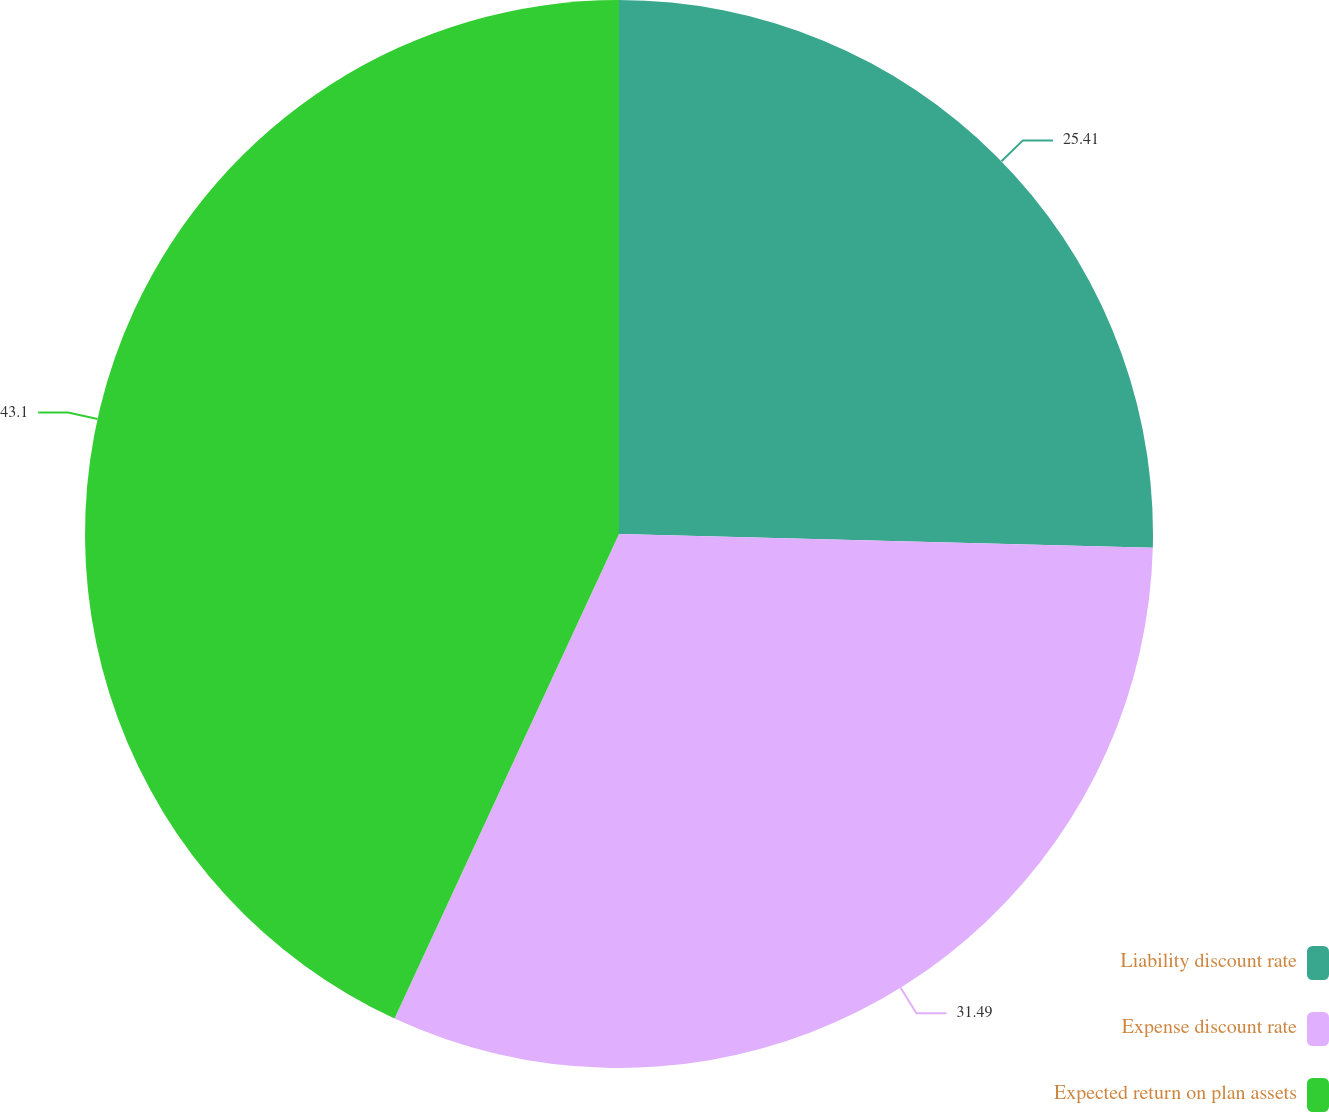Convert chart to OTSL. <chart><loc_0><loc_0><loc_500><loc_500><pie_chart><fcel>Liability discount rate<fcel>Expense discount rate<fcel>Expected return on plan assets<nl><fcel>25.41%<fcel>31.49%<fcel>43.09%<nl></chart> 